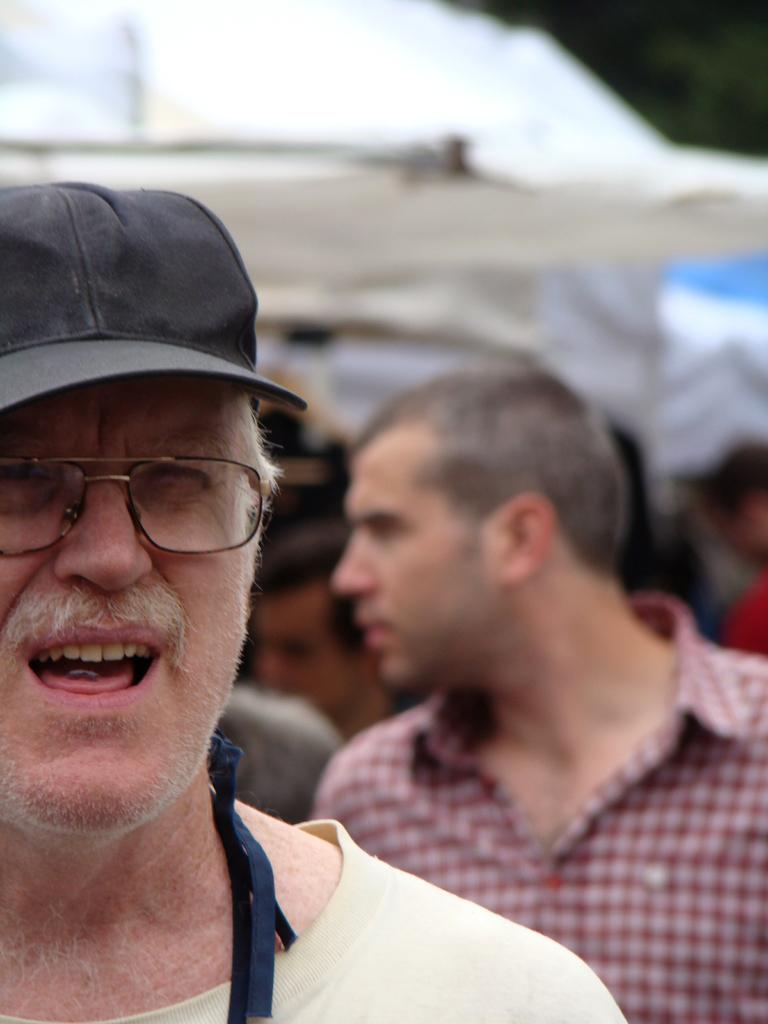Who or what can be seen in the image? There are people in the image. What are the people doing in the image? The people are standing and talking. What type of print can be seen on the people's clothing in the image? There is no information about the people's clothing or any prints in the image. 